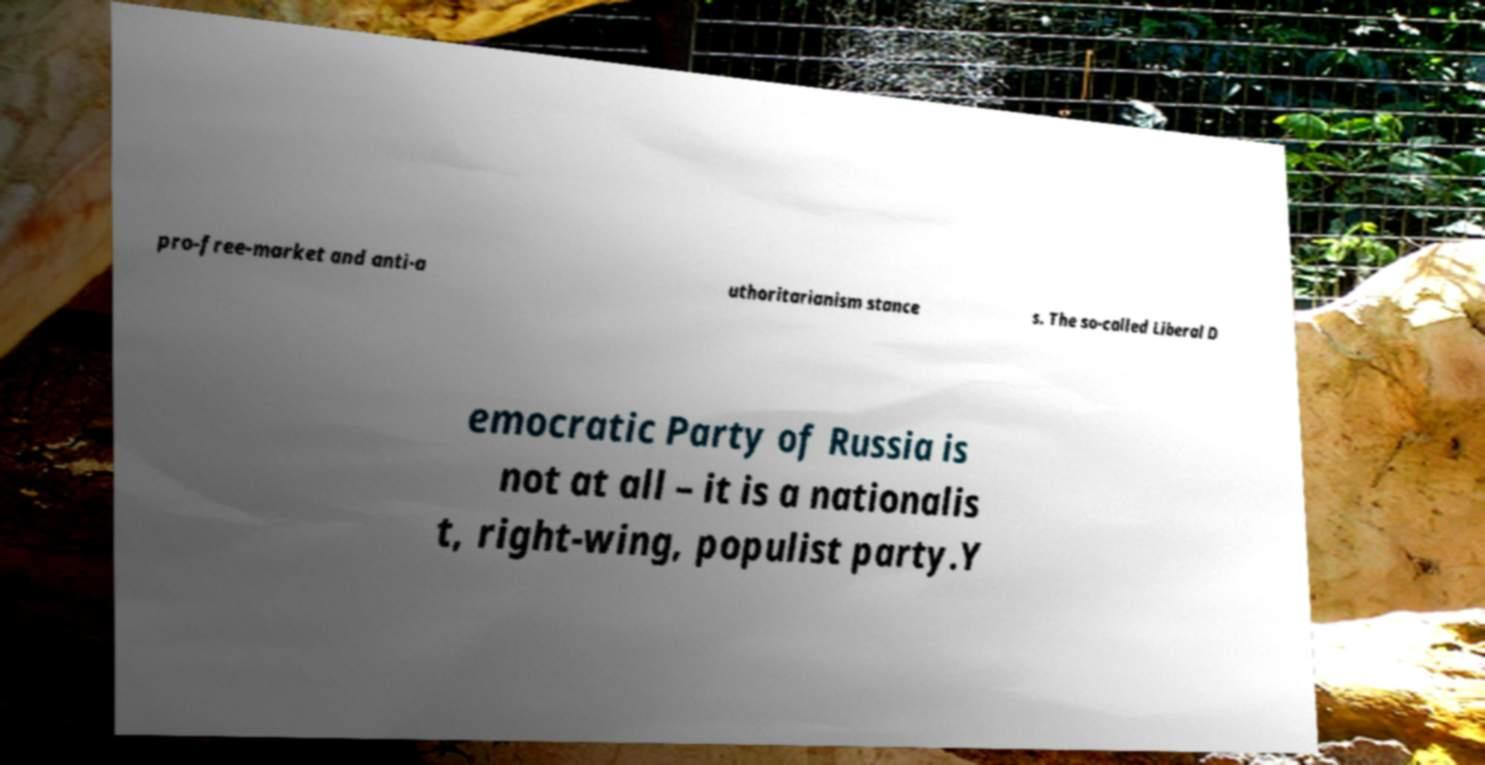Could you assist in decoding the text presented in this image and type it out clearly? pro-free-market and anti-a uthoritarianism stance s. The so-called Liberal D emocratic Party of Russia is not at all – it is a nationalis t, right-wing, populist party.Y 